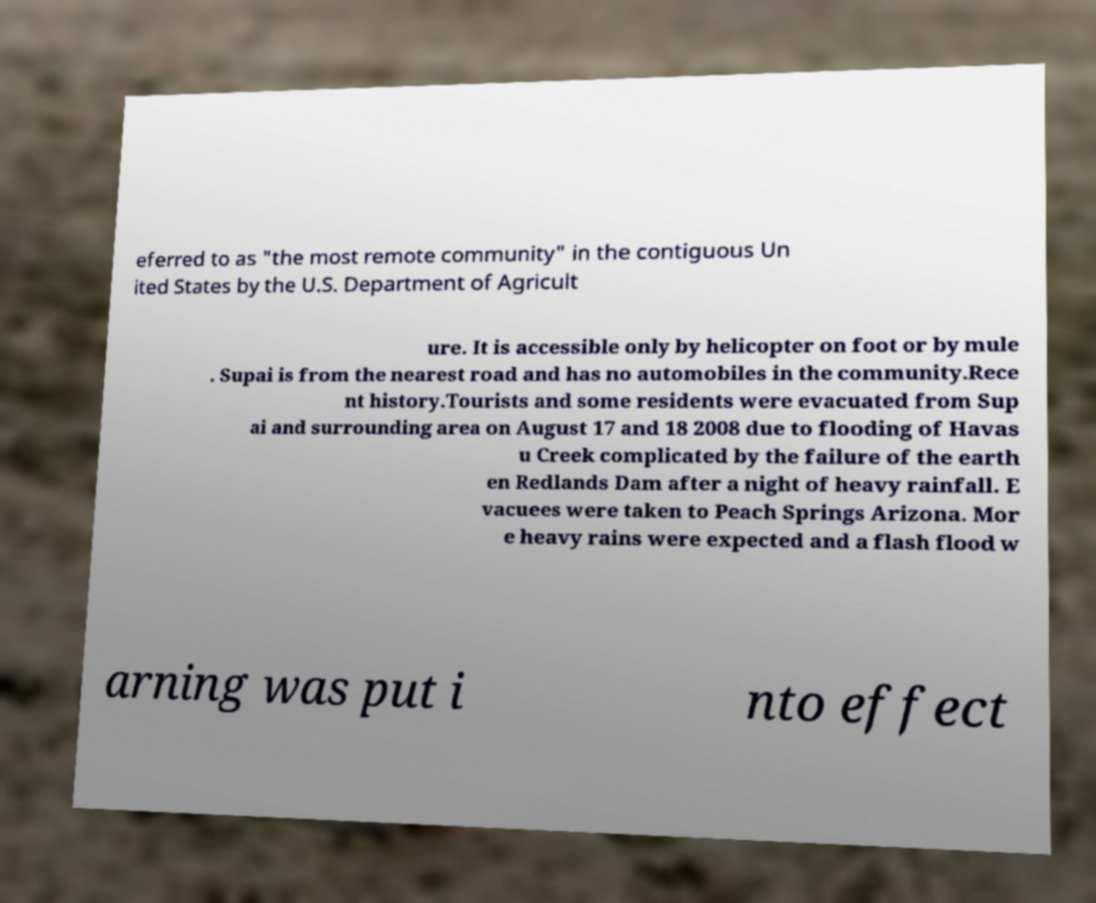I need the written content from this picture converted into text. Can you do that? eferred to as "the most remote community" in the contiguous Un ited States by the U.S. Department of Agricult ure. It is accessible only by helicopter on foot or by mule . Supai is from the nearest road and has no automobiles in the community.Rece nt history.Tourists and some residents were evacuated from Sup ai and surrounding area on August 17 and 18 2008 due to flooding of Havas u Creek complicated by the failure of the earth en Redlands Dam after a night of heavy rainfall. E vacuees were taken to Peach Springs Arizona. Mor e heavy rains were expected and a flash flood w arning was put i nto effect 